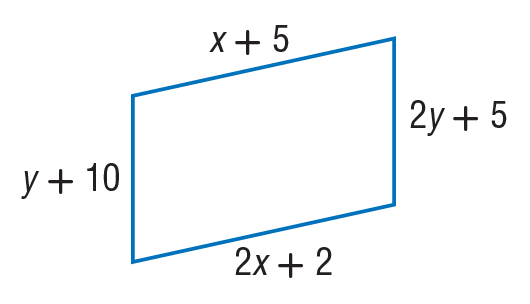Answer the mathemtical geometry problem and directly provide the correct option letter.
Question: Find y so that the quadrilateral is a parallelogram.
Choices: A: 5 B: 10 C: 12 D: 50 A 